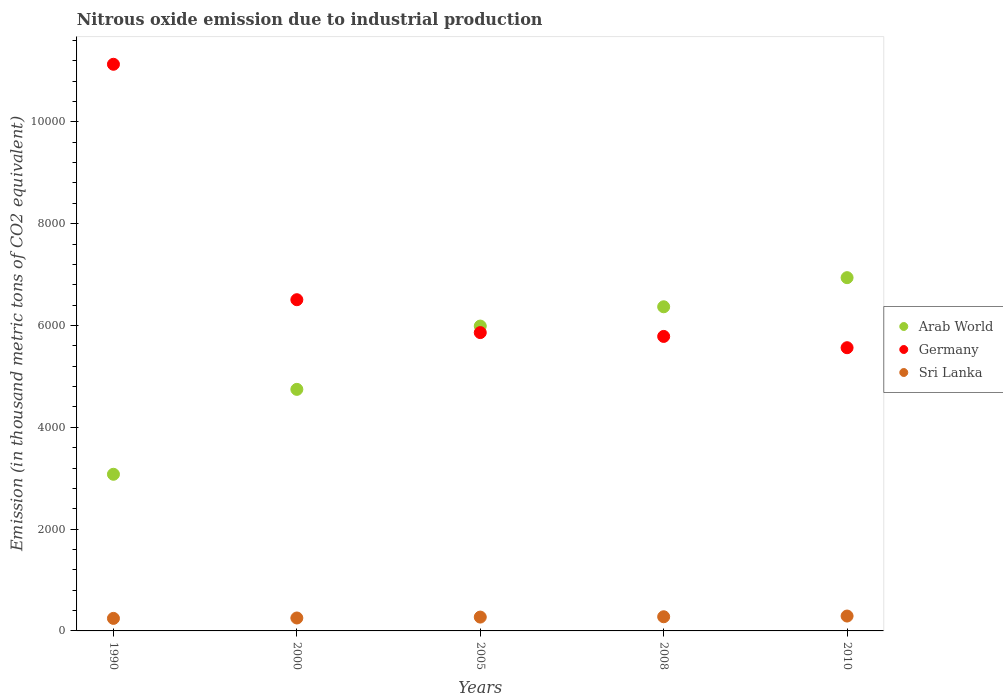How many different coloured dotlines are there?
Your answer should be compact. 3. Is the number of dotlines equal to the number of legend labels?
Provide a succinct answer. Yes. What is the amount of nitrous oxide emitted in Germany in 2000?
Keep it short and to the point. 6507. Across all years, what is the maximum amount of nitrous oxide emitted in Sri Lanka?
Keep it short and to the point. 292.4. Across all years, what is the minimum amount of nitrous oxide emitted in Germany?
Give a very brief answer. 5564. What is the total amount of nitrous oxide emitted in Arab World in the graph?
Ensure brevity in your answer.  2.71e+04. What is the difference between the amount of nitrous oxide emitted in Sri Lanka in 2000 and that in 2005?
Ensure brevity in your answer.  -17.8. What is the difference between the amount of nitrous oxide emitted in Arab World in 2000 and the amount of nitrous oxide emitted in Sri Lanka in 1990?
Your answer should be very brief. 4499.2. What is the average amount of nitrous oxide emitted in Sri Lanka per year?
Offer a very short reply. 268.56. In the year 2008, what is the difference between the amount of nitrous oxide emitted in Arab World and amount of nitrous oxide emitted in Sri Lanka?
Your response must be concise. 6089.8. What is the ratio of the amount of nitrous oxide emitted in Arab World in 2005 to that in 2008?
Provide a short and direct response. 0.94. Is the difference between the amount of nitrous oxide emitted in Arab World in 1990 and 2010 greater than the difference between the amount of nitrous oxide emitted in Sri Lanka in 1990 and 2010?
Your response must be concise. No. What is the difference between the highest and the second highest amount of nitrous oxide emitted in Arab World?
Give a very brief answer. 572.1. What is the difference between the highest and the lowest amount of nitrous oxide emitted in Arab World?
Provide a succinct answer. 3862.8. In how many years, is the amount of nitrous oxide emitted in Sri Lanka greater than the average amount of nitrous oxide emitted in Sri Lanka taken over all years?
Ensure brevity in your answer.  3. Is the sum of the amount of nitrous oxide emitted in Arab World in 1990 and 2010 greater than the maximum amount of nitrous oxide emitted in Germany across all years?
Your answer should be very brief. No. Are the values on the major ticks of Y-axis written in scientific E-notation?
Keep it short and to the point. No. Does the graph contain grids?
Offer a terse response. No. Where does the legend appear in the graph?
Your answer should be compact. Center right. How many legend labels are there?
Offer a very short reply. 3. How are the legend labels stacked?
Your response must be concise. Vertical. What is the title of the graph?
Your answer should be very brief. Nitrous oxide emission due to industrial production. What is the label or title of the X-axis?
Keep it short and to the point. Years. What is the label or title of the Y-axis?
Make the answer very short. Emission (in thousand metric tons of CO2 equivalent). What is the Emission (in thousand metric tons of CO2 equivalent) of Arab World in 1990?
Offer a terse response. 3077.4. What is the Emission (in thousand metric tons of CO2 equivalent) of Germany in 1990?
Your response must be concise. 1.11e+04. What is the Emission (in thousand metric tons of CO2 equivalent) of Sri Lanka in 1990?
Provide a short and direct response. 246.3. What is the Emission (in thousand metric tons of CO2 equivalent) of Arab World in 2000?
Your response must be concise. 4745.5. What is the Emission (in thousand metric tons of CO2 equivalent) in Germany in 2000?
Provide a succinct answer. 6507. What is the Emission (in thousand metric tons of CO2 equivalent) in Sri Lanka in 2000?
Make the answer very short. 254. What is the Emission (in thousand metric tons of CO2 equivalent) in Arab World in 2005?
Ensure brevity in your answer.  5989.1. What is the Emission (in thousand metric tons of CO2 equivalent) in Germany in 2005?
Your answer should be very brief. 5860.9. What is the Emission (in thousand metric tons of CO2 equivalent) of Sri Lanka in 2005?
Offer a terse response. 271.8. What is the Emission (in thousand metric tons of CO2 equivalent) in Arab World in 2008?
Offer a terse response. 6368.1. What is the Emission (in thousand metric tons of CO2 equivalent) in Germany in 2008?
Provide a succinct answer. 5785.7. What is the Emission (in thousand metric tons of CO2 equivalent) in Sri Lanka in 2008?
Your answer should be compact. 278.3. What is the Emission (in thousand metric tons of CO2 equivalent) of Arab World in 2010?
Offer a very short reply. 6940.2. What is the Emission (in thousand metric tons of CO2 equivalent) of Germany in 2010?
Give a very brief answer. 5564. What is the Emission (in thousand metric tons of CO2 equivalent) in Sri Lanka in 2010?
Your answer should be compact. 292.4. Across all years, what is the maximum Emission (in thousand metric tons of CO2 equivalent) of Arab World?
Your answer should be very brief. 6940.2. Across all years, what is the maximum Emission (in thousand metric tons of CO2 equivalent) of Germany?
Ensure brevity in your answer.  1.11e+04. Across all years, what is the maximum Emission (in thousand metric tons of CO2 equivalent) in Sri Lanka?
Give a very brief answer. 292.4. Across all years, what is the minimum Emission (in thousand metric tons of CO2 equivalent) in Arab World?
Keep it short and to the point. 3077.4. Across all years, what is the minimum Emission (in thousand metric tons of CO2 equivalent) in Germany?
Offer a terse response. 5564. Across all years, what is the minimum Emission (in thousand metric tons of CO2 equivalent) of Sri Lanka?
Provide a succinct answer. 246.3. What is the total Emission (in thousand metric tons of CO2 equivalent) of Arab World in the graph?
Make the answer very short. 2.71e+04. What is the total Emission (in thousand metric tons of CO2 equivalent) of Germany in the graph?
Ensure brevity in your answer.  3.48e+04. What is the total Emission (in thousand metric tons of CO2 equivalent) in Sri Lanka in the graph?
Give a very brief answer. 1342.8. What is the difference between the Emission (in thousand metric tons of CO2 equivalent) of Arab World in 1990 and that in 2000?
Make the answer very short. -1668.1. What is the difference between the Emission (in thousand metric tons of CO2 equivalent) of Germany in 1990 and that in 2000?
Give a very brief answer. 4625.2. What is the difference between the Emission (in thousand metric tons of CO2 equivalent) of Arab World in 1990 and that in 2005?
Your response must be concise. -2911.7. What is the difference between the Emission (in thousand metric tons of CO2 equivalent) of Germany in 1990 and that in 2005?
Provide a short and direct response. 5271.3. What is the difference between the Emission (in thousand metric tons of CO2 equivalent) in Sri Lanka in 1990 and that in 2005?
Your answer should be very brief. -25.5. What is the difference between the Emission (in thousand metric tons of CO2 equivalent) in Arab World in 1990 and that in 2008?
Your answer should be compact. -3290.7. What is the difference between the Emission (in thousand metric tons of CO2 equivalent) of Germany in 1990 and that in 2008?
Your response must be concise. 5346.5. What is the difference between the Emission (in thousand metric tons of CO2 equivalent) of Sri Lanka in 1990 and that in 2008?
Give a very brief answer. -32. What is the difference between the Emission (in thousand metric tons of CO2 equivalent) in Arab World in 1990 and that in 2010?
Provide a short and direct response. -3862.8. What is the difference between the Emission (in thousand metric tons of CO2 equivalent) of Germany in 1990 and that in 2010?
Your response must be concise. 5568.2. What is the difference between the Emission (in thousand metric tons of CO2 equivalent) in Sri Lanka in 1990 and that in 2010?
Provide a short and direct response. -46.1. What is the difference between the Emission (in thousand metric tons of CO2 equivalent) of Arab World in 2000 and that in 2005?
Give a very brief answer. -1243.6. What is the difference between the Emission (in thousand metric tons of CO2 equivalent) in Germany in 2000 and that in 2005?
Provide a short and direct response. 646.1. What is the difference between the Emission (in thousand metric tons of CO2 equivalent) in Sri Lanka in 2000 and that in 2005?
Offer a terse response. -17.8. What is the difference between the Emission (in thousand metric tons of CO2 equivalent) of Arab World in 2000 and that in 2008?
Ensure brevity in your answer.  -1622.6. What is the difference between the Emission (in thousand metric tons of CO2 equivalent) of Germany in 2000 and that in 2008?
Your answer should be compact. 721.3. What is the difference between the Emission (in thousand metric tons of CO2 equivalent) in Sri Lanka in 2000 and that in 2008?
Keep it short and to the point. -24.3. What is the difference between the Emission (in thousand metric tons of CO2 equivalent) of Arab World in 2000 and that in 2010?
Offer a terse response. -2194.7. What is the difference between the Emission (in thousand metric tons of CO2 equivalent) in Germany in 2000 and that in 2010?
Keep it short and to the point. 943. What is the difference between the Emission (in thousand metric tons of CO2 equivalent) in Sri Lanka in 2000 and that in 2010?
Offer a very short reply. -38.4. What is the difference between the Emission (in thousand metric tons of CO2 equivalent) of Arab World in 2005 and that in 2008?
Provide a succinct answer. -379. What is the difference between the Emission (in thousand metric tons of CO2 equivalent) of Germany in 2005 and that in 2008?
Your answer should be very brief. 75.2. What is the difference between the Emission (in thousand metric tons of CO2 equivalent) of Arab World in 2005 and that in 2010?
Provide a short and direct response. -951.1. What is the difference between the Emission (in thousand metric tons of CO2 equivalent) in Germany in 2005 and that in 2010?
Ensure brevity in your answer.  296.9. What is the difference between the Emission (in thousand metric tons of CO2 equivalent) in Sri Lanka in 2005 and that in 2010?
Your answer should be compact. -20.6. What is the difference between the Emission (in thousand metric tons of CO2 equivalent) of Arab World in 2008 and that in 2010?
Your answer should be very brief. -572.1. What is the difference between the Emission (in thousand metric tons of CO2 equivalent) in Germany in 2008 and that in 2010?
Keep it short and to the point. 221.7. What is the difference between the Emission (in thousand metric tons of CO2 equivalent) in Sri Lanka in 2008 and that in 2010?
Give a very brief answer. -14.1. What is the difference between the Emission (in thousand metric tons of CO2 equivalent) in Arab World in 1990 and the Emission (in thousand metric tons of CO2 equivalent) in Germany in 2000?
Keep it short and to the point. -3429.6. What is the difference between the Emission (in thousand metric tons of CO2 equivalent) of Arab World in 1990 and the Emission (in thousand metric tons of CO2 equivalent) of Sri Lanka in 2000?
Your response must be concise. 2823.4. What is the difference between the Emission (in thousand metric tons of CO2 equivalent) in Germany in 1990 and the Emission (in thousand metric tons of CO2 equivalent) in Sri Lanka in 2000?
Provide a succinct answer. 1.09e+04. What is the difference between the Emission (in thousand metric tons of CO2 equivalent) in Arab World in 1990 and the Emission (in thousand metric tons of CO2 equivalent) in Germany in 2005?
Your answer should be compact. -2783.5. What is the difference between the Emission (in thousand metric tons of CO2 equivalent) in Arab World in 1990 and the Emission (in thousand metric tons of CO2 equivalent) in Sri Lanka in 2005?
Make the answer very short. 2805.6. What is the difference between the Emission (in thousand metric tons of CO2 equivalent) of Germany in 1990 and the Emission (in thousand metric tons of CO2 equivalent) of Sri Lanka in 2005?
Your answer should be compact. 1.09e+04. What is the difference between the Emission (in thousand metric tons of CO2 equivalent) in Arab World in 1990 and the Emission (in thousand metric tons of CO2 equivalent) in Germany in 2008?
Provide a short and direct response. -2708.3. What is the difference between the Emission (in thousand metric tons of CO2 equivalent) in Arab World in 1990 and the Emission (in thousand metric tons of CO2 equivalent) in Sri Lanka in 2008?
Offer a terse response. 2799.1. What is the difference between the Emission (in thousand metric tons of CO2 equivalent) of Germany in 1990 and the Emission (in thousand metric tons of CO2 equivalent) of Sri Lanka in 2008?
Your response must be concise. 1.09e+04. What is the difference between the Emission (in thousand metric tons of CO2 equivalent) of Arab World in 1990 and the Emission (in thousand metric tons of CO2 equivalent) of Germany in 2010?
Keep it short and to the point. -2486.6. What is the difference between the Emission (in thousand metric tons of CO2 equivalent) of Arab World in 1990 and the Emission (in thousand metric tons of CO2 equivalent) of Sri Lanka in 2010?
Your answer should be compact. 2785. What is the difference between the Emission (in thousand metric tons of CO2 equivalent) of Germany in 1990 and the Emission (in thousand metric tons of CO2 equivalent) of Sri Lanka in 2010?
Make the answer very short. 1.08e+04. What is the difference between the Emission (in thousand metric tons of CO2 equivalent) of Arab World in 2000 and the Emission (in thousand metric tons of CO2 equivalent) of Germany in 2005?
Offer a terse response. -1115.4. What is the difference between the Emission (in thousand metric tons of CO2 equivalent) of Arab World in 2000 and the Emission (in thousand metric tons of CO2 equivalent) of Sri Lanka in 2005?
Provide a short and direct response. 4473.7. What is the difference between the Emission (in thousand metric tons of CO2 equivalent) in Germany in 2000 and the Emission (in thousand metric tons of CO2 equivalent) in Sri Lanka in 2005?
Keep it short and to the point. 6235.2. What is the difference between the Emission (in thousand metric tons of CO2 equivalent) in Arab World in 2000 and the Emission (in thousand metric tons of CO2 equivalent) in Germany in 2008?
Your answer should be compact. -1040.2. What is the difference between the Emission (in thousand metric tons of CO2 equivalent) in Arab World in 2000 and the Emission (in thousand metric tons of CO2 equivalent) in Sri Lanka in 2008?
Offer a very short reply. 4467.2. What is the difference between the Emission (in thousand metric tons of CO2 equivalent) in Germany in 2000 and the Emission (in thousand metric tons of CO2 equivalent) in Sri Lanka in 2008?
Provide a short and direct response. 6228.7. What is the difference between the Emission (in thousand metric tons of CO2 equivalent) of Arab World in 2000 and the Emission (in thousand metric tons of CO2 equivalent) of Germany in 2010?
Offer a terse response. -818.5. What is the difference between the Emission (in thousand metric tons of CO2 equivalent) of Arab World in 2000 and the Emission (in thousand metric tons of CO2 equivalent) of Sri Lanka in 2010?
Make the answer very short. 4453.1. What is the difference between the Emission (in thousand metric tons of CO2 equivalent) of Germany in 2000 and the Emission (in thousand metric tons of CO2 equivalent) of Sri Lanka in 2010?
Your answer should be very brief. 6214.6. What is the difference between the Emission (in thousand metric tons of CO2 equivalent) of Arab World in 2005 and the Emission (in thousand metric tons of CO2 equivalent) of Germany in 2008?
Provide a short and direct response. 203.4. What is the difference between the Emission (in thousand metric tons of CO2 equivalent) of Arab World in 2005 and the Emission (in thousand metric tons of CO2 equivalent) of Sri Lanka in 2008?
Keep it short and to the point. 5710.8. What is the difference between the Emission (in thousand metric tons of CO2 equivalent) of Germany in 2005 and the Emission (in thousand metric tons of CO2 equivalent) of Sri Lanka in 2008?
Offer a very short reply. 5582.6. What is the difference between the Emission (in thousand metric tons of CO2 equivalent) in Arab World in 2005 and the Emission (in thousand metric tons of CO2 equivalent) in Germany in 2010?
Give a very brief answer. 425.1. What is the difference between the Emission (in thousand metric tons of CO2 equivalent) in Arab World in 2005 and the Emission (in thousand metric tons of CO2 equivalent) in Sri Lanka in 2010?
Your response must be concise. 5696.7. What is the difference between the Emission (in thousand metric tons of CO2 equivalent) of Germany in 2005 and the Emission (in thousand metric tons of CO2 equivalent) of Sri Lanka in 2010?
Make the answer very short. 5568.5. What is the difference between the Emission (in thousand metric tons of CO2 equivalent) of Arab World in 2008 and the Emission (in thousand metric tons of CO2 equivalent) of Germany in 2010?
Keep it short and to the point. 804.1. What is the difference between the Emission (in thousand metric tons of CO2 equivalent) of Arab World in 2008 and the Emission (in thousand metric tons of CO2 equivalent) of Sri Lanka in 2010?
Offer a very short reply. 6075.7. What is the difference between the Emission (in thousand metric tons of CO2 equivalent) in Germany in 2008 and the Emission (in thousand metric tons of CO2 equivalent) in Sri Lanka in 2010?
Provide a succinct answer. 5493.3. What is the average Emission (in thousand metric tons of CO2 equivalent) in Arab World per year?
Provide a short and direct response. 5424.06. What is the average Emission (in thousand metric tons of CO2 equivalent) in Germany per year?
Ensure brevity in your answer.  6969.96. What is the average Emission (in thousand metric tons of CO2 equivalent) of Sri Lanka per year?
Your answer should be compact. 268.56. In the year 1990, what is the difference between the Emission (in thousand metric tons of CO2 equivalent) of Arab World and Emission (in thousand metric tons of CO2 equivalent) of Germany?
Provide a succinct answer. -8054.8. In the year 1990, what is the difference between the Emission (in thousand metric tons of CO2 equivalent) in Arab World and Emission (in thousand metric tons of CO2 equivalent) in Sri Lanka?
Your response must be concise. 2831.1. In the year 1990, what is the difference between the Emission (in thousand metric tons of CO2 equivalent) in Germany and Emission (in thousand metric tons of CO2 equivalent) in Sri Lanka?
Offer a very short reply. 1.09e+04. In the year 2000, what is the difference between the Emission (in thousand metric tons of CO2 equivalent) of Arab World and Emission (in thousand metric tons of CO2 equivalent) of Germany?
Your answer should be very brief. -1761.5. In the year 2000, what is the difference between the Emission (in thousand metric tons of CO2 equivalent) of Arab World and Emission (in thousand metric tons of CO2 equivalent) of Sri Lanka?
Give a very brief answer. 4491.5. In the year 2000, what is the difference between the Emission (in thousand metric tons of CO2 equivalent) in Germany and Emission (in thousand metric tons of CO2 equivalent) in Sri Lanka?
Offer a very short reply. 6253. In the year 2005, what is the difference between the Emission (in thousand metric tons of CO2 equivalent) in Arab World and Emission (in thousand metric tons of CO2 equivalent) in Germany?
Give a very brief answer. 128.2. In the year 2005, what is the difference between the Emission (in thousand metric tons of CO2 equivalent) in Arab World and Emission (in thousand metric tons of CO2 equivalent) in Sri Lanka?
Your answer should be very brief. 5717.3. In the year 2005, what is the difference between the Emission (in thousand metric tons of CO2 equivalent) of Germany and Emission (in thousand metric tons of CO2 equivalent) of Sri Lanka?
Provide a short and direct response. 5589.1. In the year 2008, what is the difference between the Emission (in thousand metric tons of CO2 equivalent) of Arab World and Emission (in thousand metric tons of CO2 equivalent) of Germany?
Provide a short and direct response. 582.4. In the year 2008, what is the difference between the Emission (in thousand metric tons of CO2 equivalent) of Arab World and Emission (in thousand metric tons of CO2 equivalent) of Sri Lanka?
Your answer should be compact. 6089.8. In the year 2008, what is the difference between the Emission (in thousand metric tons of CO2 equivalent) in Germany and Emission (in thousand metric tons of CO2 equivalent) in Sri Lanka?
Offer a very short reply. 5507.4. In the year 2010, what is the difference between the Emission (in thousand metric tons of CO2 equivalent) of Arab World and Emission (in thousand metric tons of CO2 equivalent) of Germany?
Offer a very short reply. 1376.2. In the year 2010, what is the difference between the Emission (in thousand metric tons of CO2 equivalent) in Arab World and Emission (in thousand metric tons of CO2 equivalent) in Sri Lanka?
Your answer should be compact. 6647.8. In the year 2010, what is the difference between the Emission (in thousand metric tons of CO2 equivalent) of Germany and Emission (in thousand metric tons of CO2 equivalent) of Sri Lanka?
Offer a terse response. 5271.6. What is the ratio of the Emission (in thousand metric tons of CO2 equivalent) of Arab World in 1990 to that in 2000?
Your response must be concise. 0.65. What is the ratio of the Emission (in thousand metric tons of CO2 equivalent) of Germany in 1990 to that in 2000?
Your answer should be compact. 1.71. What is the ratio of the Emission (in thousand metric tons of CO2 equivalent) in Sri Lanka in 1990 to that in 2000?
Make the answer very short. 0.97. What is the ratio of the Emission (in thousand metric tons of CO2 equivalent) of Arab World in 1990 to that in 2005?
Keep it short and to the point. 0.51. What is the ratio of the Emission (in thousand metric tons of CO2 equivalent) in Germany in 1990 to that in 2005?
Your response must be concise. 1.9. What is the ratio of the Emission (in thousand metric tons of CO2 equivalent) of Sri Lanka in 1990 to that in 2005?
Your response must be concise. 0.91. What is the ratio of the Emission (in thousand metric tons of CO2 equivalent) of Arab World in 1990 to that in 2008?
Your answer should be very brief. 0.48. What is the ratio of the Emission (in thousand metric tons of CO2 equivalent) in Germany in 1990 to that in 2008?
Ensure brevity in your answer.  1.92. What is the ratio of the Emission (in thousand metric tons of CO2 equivalent) in Sri Lanka in 1990 to that in 2008?
Your answer should be very brief. 0.89. What is the ratio of the Emission (in thousand metric tons of CO2 equivalent) in Arab World in 1990 to that in 2010?
Your answer should be compact. 0.44. What is the ratio of the Emission (in thousand metric tons of CO2 equivalent) in Germany in 1990 to that in 2010?
Offer a very short reply. 2. What is the ratio of the Emission (in thousand metric tons of CO2 equivalent) of Sri Lanka in 1990 to that in 2010?
Ensure brevity in your answer.  0.84. What is the ratio of the Emission (in thousand metric tons of CO2 equivalent) of Arab World in 2000 to that in 2005?
Give a very brief answer. 0.79. What is the ratio of the Emission (in thousand metric tons of CO2 equivalent) of Germany in 2000 to that in 2005?
Make the answer very short. 1.11. What is the ratio of the Emission (in thousand metric tons of CO2 equivalent) of Sri Lanka in 2000 to that in 2005?
Provide a short and direct response. 0.93. What is the ratio of the Emission (in thousand metric tons of CO2 equivalent) in Arab World in 2000 to that in 2008?
Your answer should be very brief. 0.75. What is the ratio of the Emission (in thousand metric tons of CO2 equivalent) of Germany in 2000 to that in 2008?
Offer a terse response. 1.12. What is the ratio of the Emission (in thousand metric tons of CO2 equivalent) in Sri Lanka in 2000 to that in 2008?
Keep it short and to the point. 0.91. What is the ratio of the Emission (in thousand metric tons of CO2 equivalent) of Arab World in 2000 to that in 2010?
Make the answer very short. 0.68. What is the ratio of the Emission (in thousand metric tons of CO2 equivalent) in Germany in 2000 to that in 2010?
Your response must be concise. 1.17. What is the ratio of the Emission (in thousand metric tons of CO2 equivalent) of Sri Lanka in 2000 to that in 2010?
Offer a very short reply. 0.87. What is the ratio of the Emission (in thousand metric tons of CO2 equivalent) in Arab World in 2005 to that in 2008?
Ensure brevity in your answer.  0.94. What is the ratio of the Emission (in thousand metric tons of CO2 equivalent) in Sri Lanka in 2005 to that in 2008?
Provide a short and direct response. 0.98. What is the ratio of the Emission (in thousand metric tons of CO2 equivalent) in Arab World in 2005 to that in 2010?
Your answer should be very brief. 0.86. What is the ratio of the Emission (in thousand metric tons of CO2 equivalent) in Germany in 2005 to that in 2010?
Ensure brevity in your answer.  1.05. What is the ratio of the Emission (in thousand metric tons of CO2 equivalent) in Sri Lanka in 2005 to that in 2010?
Your answer should be compact. 0.93. What is the ratio of the Emission (in thousand metric tons of CO2 equivalent) of Arab World in 2008 to that in 2010?
Give a very brief answer. 0.92. What is the ratio of the Emission (in thousand metric tons of CO2 equivalent) of Germany in 2008 to that in 2010?
Your answer should be compact. 1.04. What is the ratio of the Emission (in thousand metric tons of CO2 equivalent) of Sri Lanka in 2008 to that in 2010?
Keep it short and to the point. 0.95. What is the difference between the highest and the second highest Emission (in thousand metric tons of CO2 equivalent) of Arab World?
Provide a succinct answer. 572.1. What is the difference between the highest and the second highest Emission (in thousand metric tons of CO2 equivalent) of Germany?
Your response must be concise. 4625.2. What is the difference between the highest and the second highest Emission (in thousand metric tons of CO2 equivalent) in Sri Lanka?
Provide a succinct answer. 14.1. What is the difference between the highest and the lowest Emission (in thousand metric tons of CO2 equivalent) of Arab World?
Ensure brevity in your answer.  3862.8. What is the difference between the highest and the lowest Emission (in thousand metric tons of CO2 equivalent) in Germany?
Offer a terse response. 5568.2. What is the difference between the highest and the lowest Emission (in thousand metric tons of CO2 equivalent) of Sri Lanka?
Your response must be concise. 46.1. 